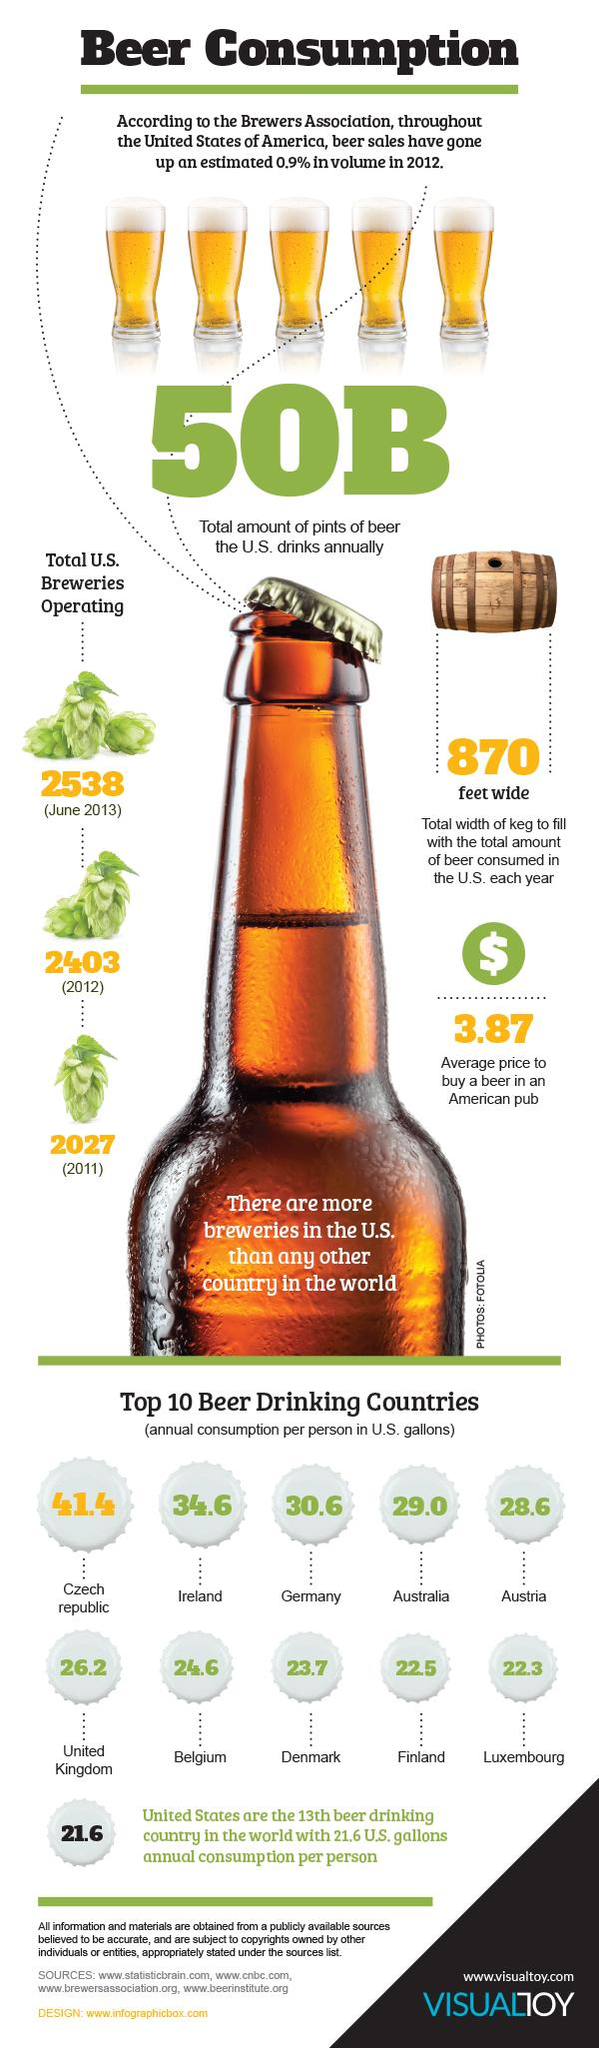Outline some significant characteristics in this image. Finland is the second country with the lowest beer consumption. It is being discussed which drink is being consumed, and the consensus is that it is beer. The increase in breweries from 2012 to 2013 was 135. The average annual consumption between Finland and the US is 0.9. The average annual consumption of Germany and Australia is 29.8 megatons of greenhouse gases. 